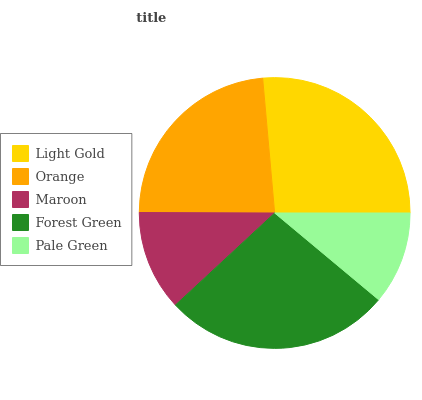Is Pale Green the minimum?
Answer yes or no. Yes. Is Forest Green the maximum?
Answer yes or no. Yes. Is Orange the minimum?
Answer yes or no. No. Is Orange the maximum?
Answer yes or no. No. Is Light Gold greater than Orange?
Answer yes or no. Yes. Is Orange less than Light Gold?
Answer yes or no. Yes. Is Orange greater than Light Gold?
Answer yes or no. No. Is Light Gold less than Orange?
Answer yes or no. No. Is Orange the high median?
Answer yes or no. Yes. Is Orange the low median?
Answer yes or no. Yes. Is Light Gold the high median?
Answer yes or no. No. Is Forest Green the low median?
Answer yes or no. No. 